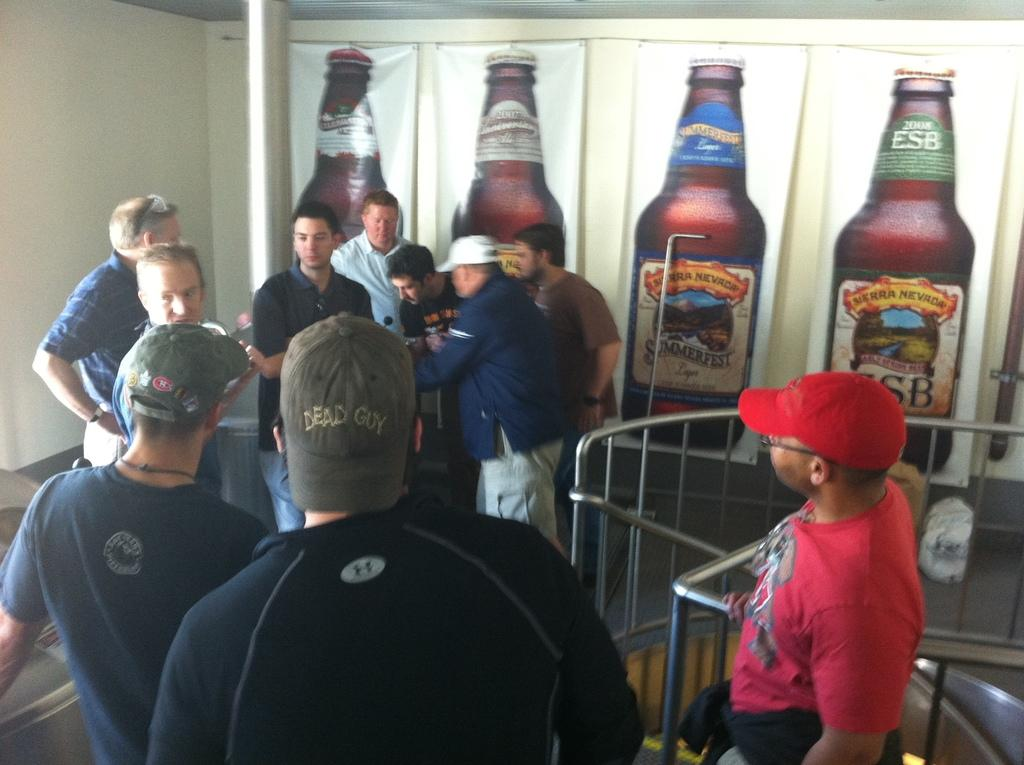What is the main subject of the banner in the image? The main subject of the banner in the image is bottles. Where is the banner located? The banner is over a wall. What else can be seen in the image besides the banner? There are persons standing on the floor in the image. How does the banner control the flow of water in the image? The banner does not control the flow of water in the image; it is a banner of bottles hanging over a wall. 